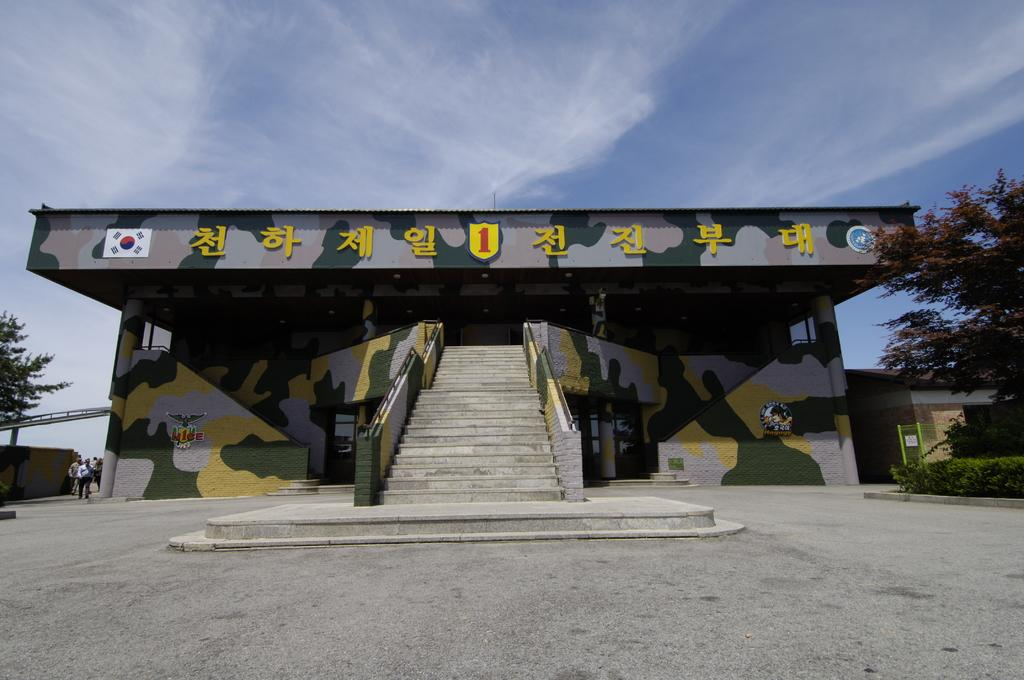What is the primary surface visible in the image? There is a ground in the image. What type of structure is present on the ground? There is a building with stairs on the ground. Are there any people in the image? Yes, there are persons beside the building. What type of vegetation can be seen in the image? Trees and plants are visible in the image. What architectural feature is present in the image? There is a fence in the image. What other man-made structure is present in the image? There is a wall in the image. What part of the natural environment is visible in the image? The sky is visible in the image. How many cats are sitting on the island in the image? There is no island or cats present in the image. What type of lead is being used by the persons in the image? There is no mention of any lead or activity involving lead in the image. 